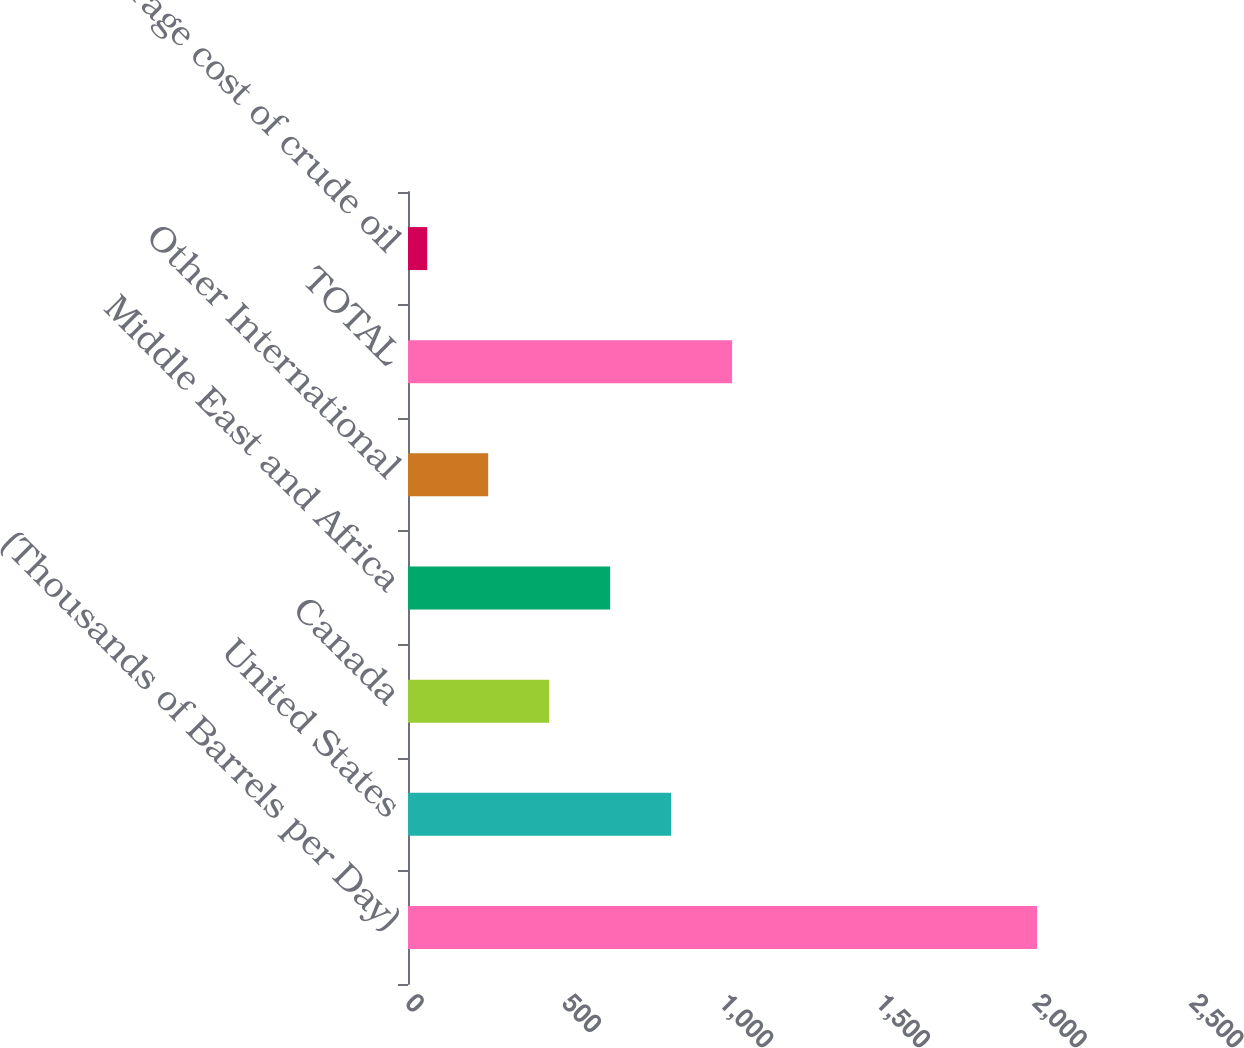<chart> <loc_0><loc_0><loc_500><loc_500><bar_chart><fcel>(Thousands of Barrels per Day)<fcel>United States<fcel>Canada<fcel>Middle East and Africa<fcel>Other International<fcel>TOTAL<fcel>Average cost of crude oil<nl><fcel>2006<fcel>839.1<fcel>450.12<fcel>644.61<fcel>255.64<fcel>1033.59<fcel>61.15<nl></chart> 